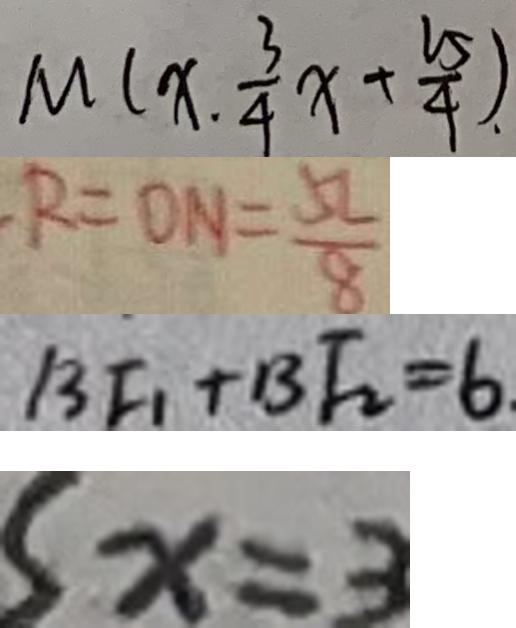Convert formula to latex. <formula><loc_0><loc_0><loc_500><loc_500>M ( x . \frac { 3 } { 4 } x + \frac { 2 5 } { 4 } ) . 
 R = O N = \frac { 5 L } { 8 } 
 B F _ { 1 } + B F _ { 2 } = 6 . 
 S x = 3</formula> 